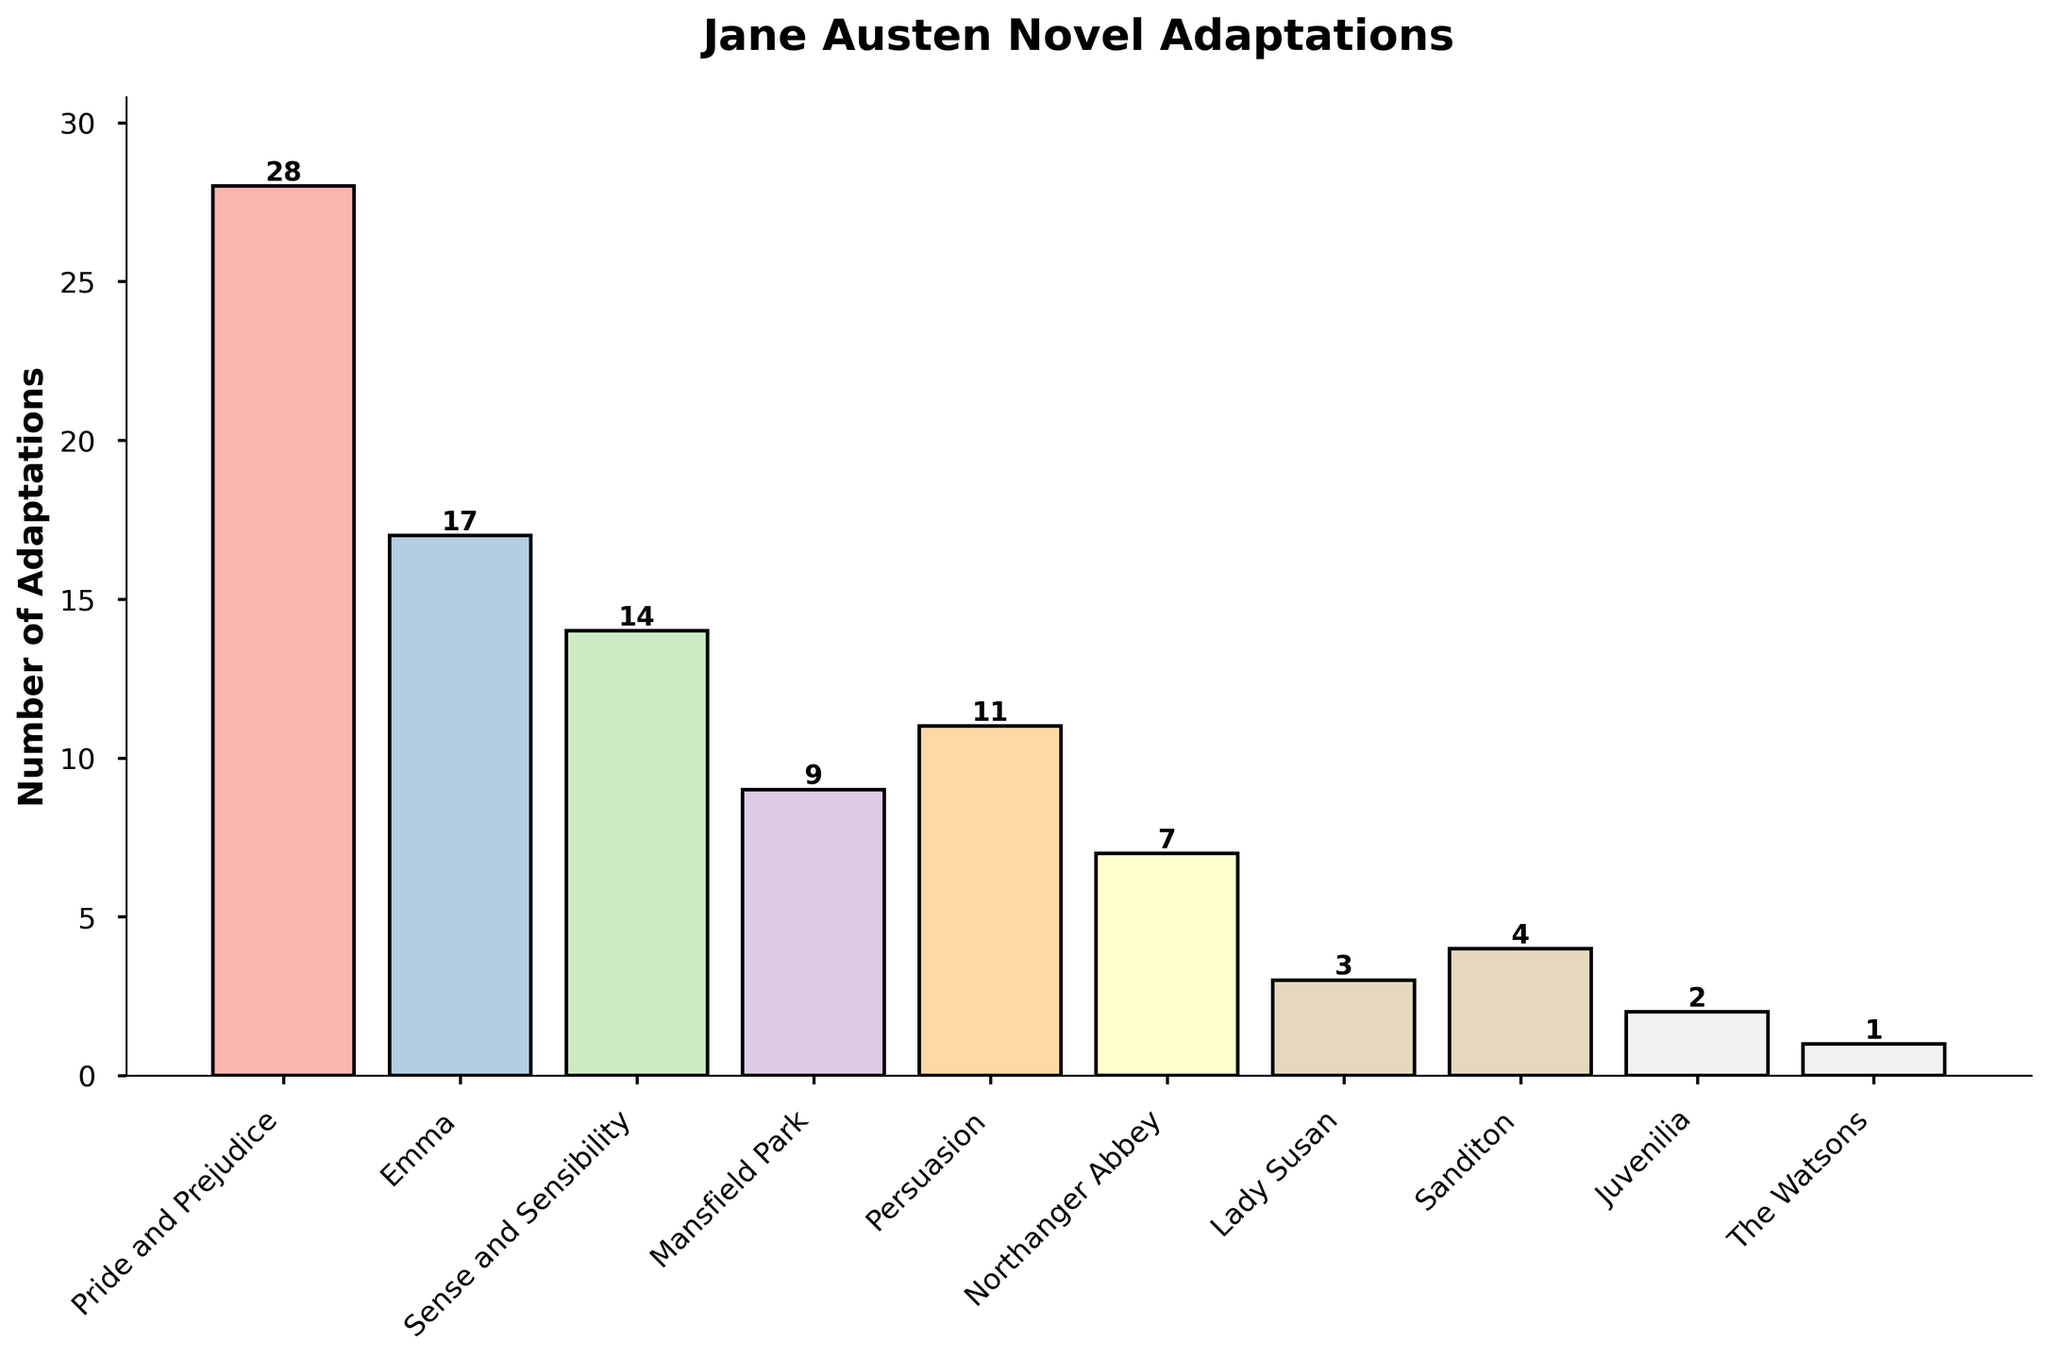Which novel has the highest number of adaptations? The height of the bars represents the number of adaptations for each novel. The tallest bar corresponds to "Pride and Prejudice."
Answer: Pride and Prejudice How many more adaptations does "Emma" have compared to "Sanditon"? "Emma" has 17 adaptations and "Sanditon" has 4. The difference is 17 - 4 = 13.
Answer: 13 What is the total number of adaptations for "Sense and Sensibility" and "Persuasion"? The number of adaptations for "Sense and Sensibility" is 14 and for "Persuasion" is 11. Adding them together gives 14 + 11 = 25.
Answer: 25 How does the number of adaptations for "Northanger Abbey" compare to "Mansfield Park"? "Northanger Abbey" has 7 adaptations, while "Mansfield Park" has 9. Comparing them shows that "Northanger Abbey" has 2 fewer adaptations.
Answer: 2 fewer Which novels have fewer than 5 adaptations? From the chart, "Lady Susan," "Sanditon," "Juvenilia," and "The Watsons" each have fewer than 5 adaptations.
Answer: Lady Susan, Sanditon, Juvenilia, The Watsons What is the average number of adaptations for "Pride and Prejudice," "Emma," and "Sense and Sensibility"? The total number of adaptations for these novels: 28 (Pride and Prejudice) + 17 (Emma) + 14 (Sense and Sensibility) = 59. The average is 59 / 3 ≈ 19.67.
Answer: 19.67 Do "Pride and Prejudice" and "Emma" together have more adaptations than all the other novels combined? "Pride and Prejudice" and "Emma" together have 28 + 17 = 45 adaptations. The total for all other novels is 14 + 9 + 11 + 7 + 3 + 4 + 2 + 1 = 51. 45 is less than 51.
Answer: No Which bar is the shortest in the chart? The height of the bars represents the number of adaptations. The shortest bar corresponds to "The Watsons."
Answer: The Watsons What is the median number of adaptations for all the novels? First, list the number of adaptations in ascending order: 1, 2, 3, 4, 7, 9, 11, 14, 17, 28. The median is the average of the 5th and 6th values: (7 + 9) / 2 = 8.
Answer: 8 